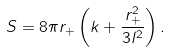Convert formula to latex. <formula><loc_0><loc_0><loc_500><loc_500>S = 8 \pi r _ { + } \left ( k + \frac { r _ { + } ^ { 2 } } { 3 l ^ { 2 } } \right ) .</formula> 